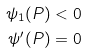Convert formula to latex. <formula><loc_0><loc_0><loc_500><loc_500>\psi _ { 1 } ( P ) & < 0 \\ \psi ^ { \prime } ( P ) & = 0</formula> 